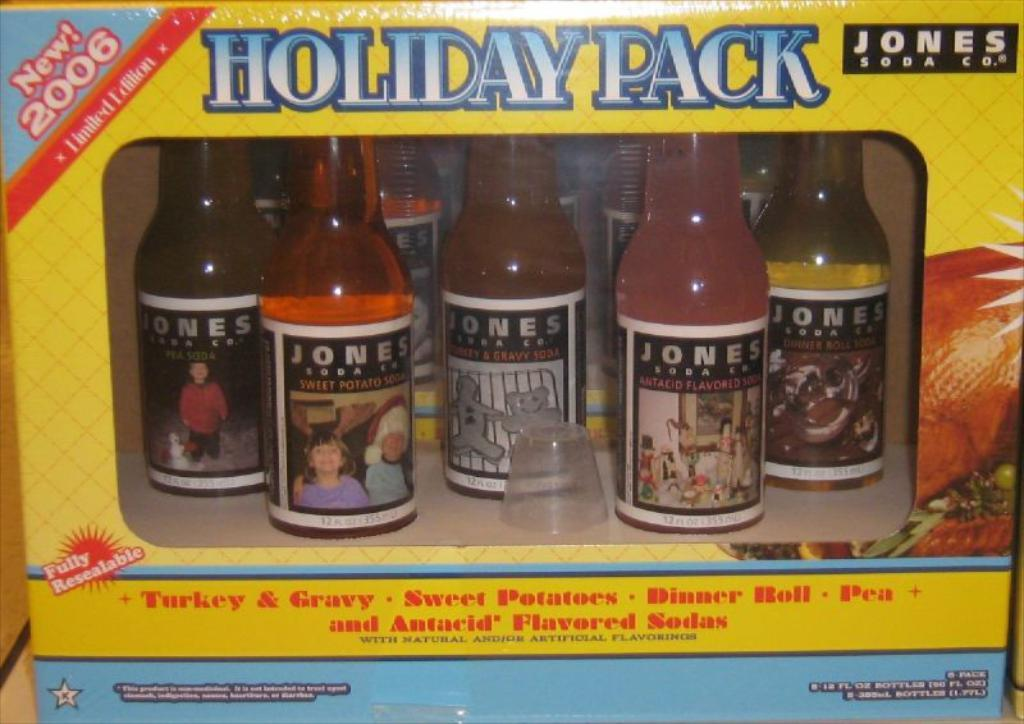<image>
Provide a brief description of the given image. the words Holiday Pack are on a yellow box 